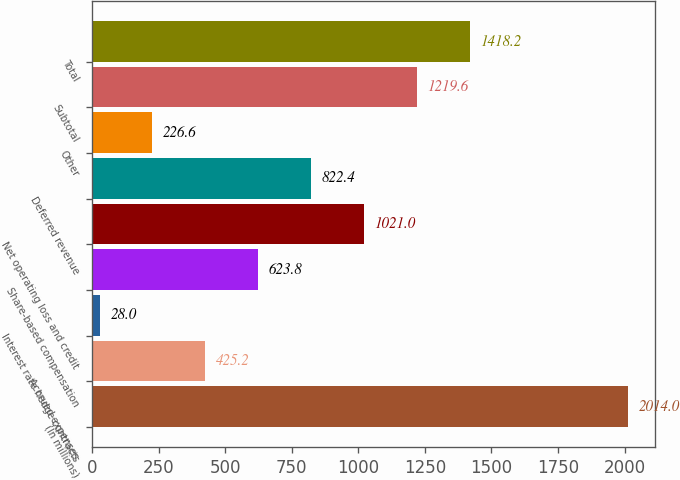Convert chart. <chart><loc_0><loc_0><loc_500><loc_500><bar_chart><fcel>(In millions)<fcel>Accrued expenses<fcel>Interest rate hedge contracts<fcel>Share-based compensation<fcel>Net operating loss and credit<fcel>Deferred revenue<fcel>Other<fcel>Subtotal<fcel>Total<nl><fcel>2014<fcel>425.2<fcel>28<fcel>623.8<fcel>1021<fcel>822.4<fcel>226.6<fcel>1219.6<fcel>1418.2<nl></chart> 